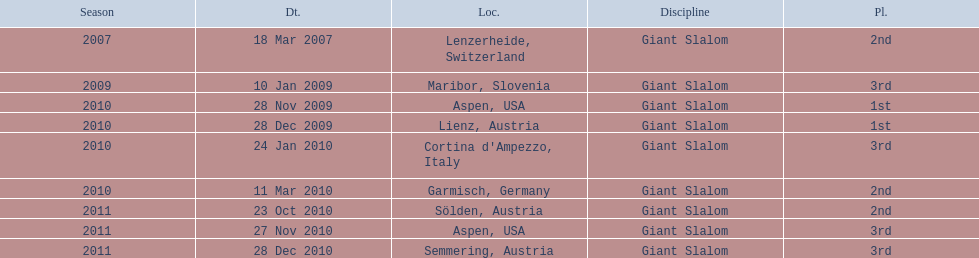Where was her first win? Aspen, USA. 